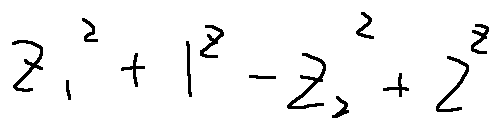Convert formula to latex. <formula><loc_0><loc_0><loc_500><loc_500>z _ { 1 } ^ { 2 } + 1 ^ { z } - z _ { 2 } ^ { 2 } + 2 ^ { z }</formula> 